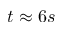<formula> <loc_0><loc_0><loc_500><loc_500>t \approx 6 s</formula> 